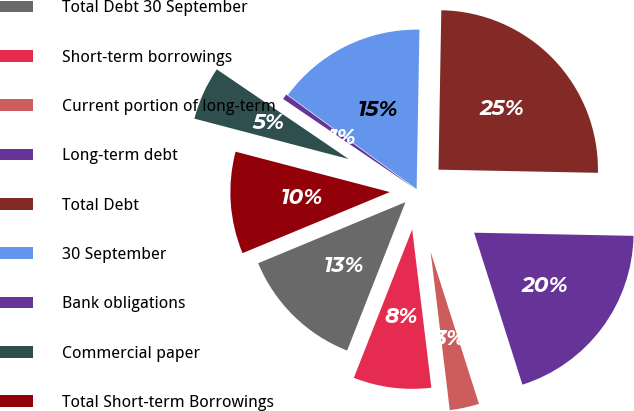Convert chart. <chart><loc_0><loc_0><loc_500><loc_500><pie_chart><fcel>Total Debt 30 September<fcel>Short-term borrowings<fcel>Current portion of long-term<fcel>Long-term debt<fcel>Total Debt<fcel>30 September<fcel>Bank obligations<fcel>Commercial paper<fcel>Total Short-term Borrowings<nl><fcel>12.78%<fcel>7.88%<fcel>2.98%<fcel>19.78%<fcel>25.03%<fcel>15.23%<fcel>0.54%<fcel>5.43%<fcel>10.33%<nl></chart> 